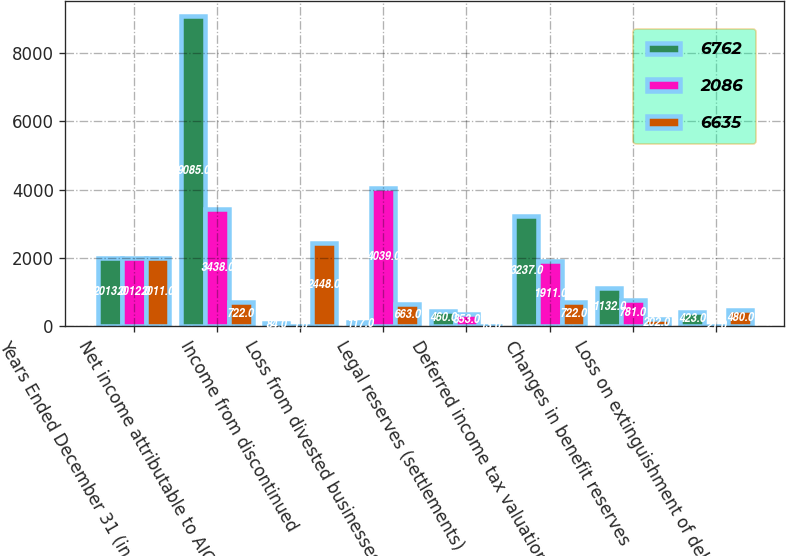Convert chart to OTSL. <chart><loc_0><loc_0><loc_500><loc_500><stacked_bar_chart><ecel><fcel>Years Ended December 31 (in<fcel>Net income attributable to AIG<fcel>Income from discontinued<fcel>Loss from divested businesses<fcel>Legal reserves (settlements)<fcel>Deferred income tax valuation<fcel>Changes in benefit reserves<fcel>Loss on extinguishment of debt<nl><fcel>6762<fcel>2013<fcel>9085<fcel>84<fcel>117<fcel>460<fcel>3237<fcel>1132<fcel>423<nl><fcel>2086<fcel>2012<fcel>3438<fcel>1<fcel>4039<fcel>353<fcel>1911<fcel>781<fcel>21<nl><fcel>6635<fcel>2011<fcel>722<fcel>2448<fcel>663<fcel>13<fcel>722<fcel>202<fcel>480<nl></chart> 